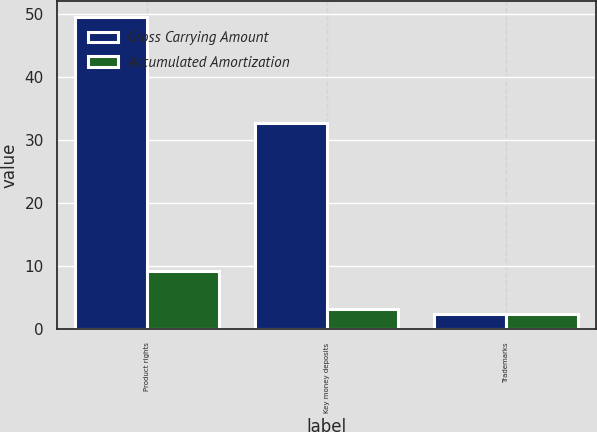Convert chart to OTSL. <chart><loc_0><loc_0><loc_500><loc_500><stacked_bar_chart><ecel><fcel>Product rights<fcel>Key money deposits<fcel>Trademarks<nl><fcel>Gross Carrying Amount<fcel>49.6<fcel>32.7<fcel>2.5<nl><fcel>Accumulated Amortization<fcel>9.2<fcel>3.3<fcel>2.5<nl></chart> 